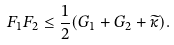<formula> <loc_0><loc_0><loc_500><loc_500>F _ { 1 } F _ { 2 } \leq \frac { 1 } { 2 } ( G _ { 1 } + G _ { 2 } + \widetilde { \kappa } ) .</formula> 